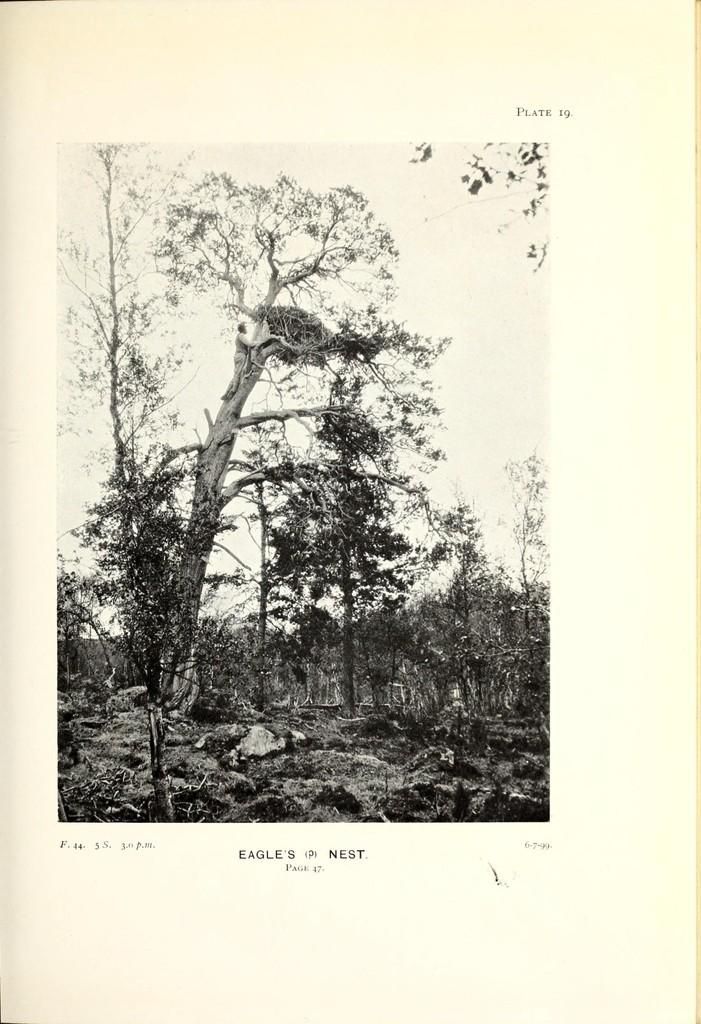What is depicted on the page in the image? The page contains trees, a person, the sky, and text. Can you describe the elements related to nature on the page? The page contains trees and the sky. What type of human figure is present on the page? The page contains a person. Is there any text present on the page? Yes, there is text on the page. What type of root can be seen growing from the person's head in the image? There is no root growing from the person's head in the image; it only contains trees, the sky, and text. What type of industry is depicted in the image? There is no industry depicted in the image; it only contains trees, the sky, a person, and text. 